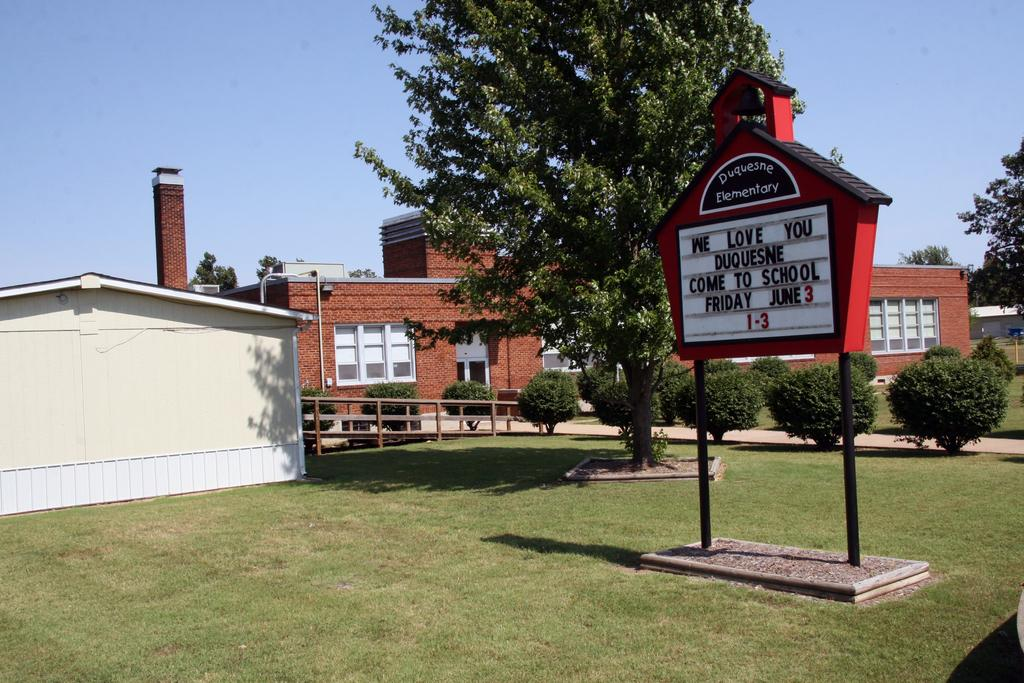What is the main object in the image? There is a name board in the image. What type of natural environment is depicted in the image? There are trees and grass in the image. Is there a specific route or path visible in the image? Yes, there is a path in the image. What type of structures can be seen in the image? There are houses with windows in the image. What can be seen in the background of the image? The sky is visible in the background of the image. What type of quiver is hanging on the trees in the image? There is no quiver present in the image; it features a name board, trees, grass, a path, houses with windows, and a visible sky. Can you describe the fog in the image? There is no fog present in the image; it is a clear image with a visible sky. 